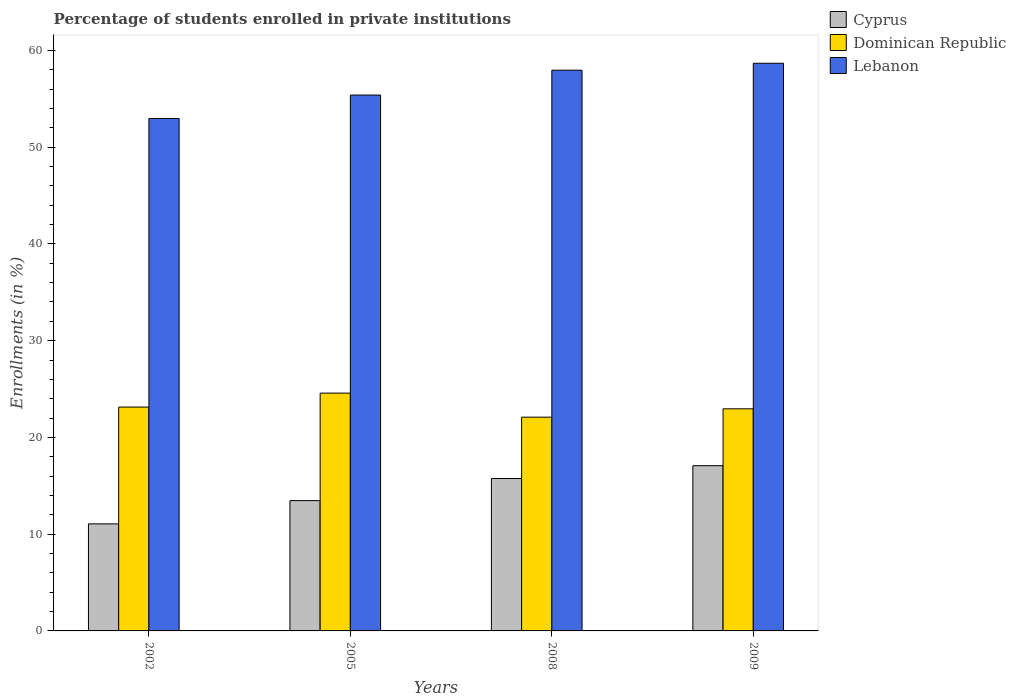In how many cases, is the number of bars for a given year not equal to the number of legend labels?
Your answer should be very brief. 0. What is the percentage of trained teachers in Lebanon in 2009?
Make the answer very short. 58.67. Across all years, what is the maximum percentage of trained teachers in Cyprus?
Give a very brief answer. 17.08. Across all years, what is the minimum percentage of trained teachers in Lebanon?
Your response must be concise. 52.96. In which year was the percentage of trained teachers in Lebanon maximum?
Ensure brevity in your answer.  2009. What is the total percentage of trained teachers in Lebanon in the graph?
Provide a succinct answer. 224.97. What is the difference between the percentage of trained teachers in Cyprus in 2008 and that in 2009?
Your answer should be very brief. -1.33. What is the difference between the percentage of trained teachers in Cyprus in 2008 and the percentage of trained teachers in Dominican Republic in 2002?
Keep it short and to the point. -7.38. What is the average percentage of trained teachers in Dominican Republic per year?
Your answer should be compact. 23.19. In the year 2002, what is the difference between the percentage of trained teachers in Cyprus and percentage of trained teachers in Lebanon?
Give a very brief answer. -41.9. What is the ratio of the percentage of trained teachers in Lebanon in 2008 to that in 2009?
Ensure brevity in your answer.  0.99. Is the percentage of trained teachers in Cyprus in 2008 less than that in 2009?
Give a very brief answer. Yes. Is the difference between the percentage of trained teachers in Cyprus in 2002 and 2008 greater than the difference between the percentage of trained teachers in Lebanon in 2002 and 2008?
Offer a very short reply. Yes. What is the difference between the highest and the second highest percentage of trained teachers in Lebanon?
Offer a terse response. 0.72. What is the difference between the highest and the lowest percentage of trained teachers in Cyprus?
Your response must be concise. 6.01. In how many years, is the percentage of trained teachers in Cyprus greater than the average percentage of trained teachers in Cyprus taken over all years?
Make the answer very short. 2. What does the 3rd bar from the left in 2008 represents?
Give a very brief answer. Lebanon. What does the 2nd bar from the right in 2009 represents?
Your answer should be very brief. Dominican Republic. Is it the case that in every year, the sum of the percentage of trained teachers in Lebanon and percentage of trained teachers in Dominican Republic is greater than the percentage of trained teachers in Cyprus?
Provide a short and direct response. Yes. How many bars are there?
Offer a terse response. 12. Are all the bars in the graph horizontal?
Make the answer very short. No. Are the values on the major ticks of Y-axis written in scientific E-notation?
Give a very brief answer. No. Does the graph contain any zero values?
Keep it short and to the point. No. Does the graph contain grids?
Your answer should be very brief. No. How many legend labels are there?
Keep it short and to the point. 3. How are the legend labels stacked?
Provide a short and direct response. Vertical. What is the title of the graph?
Make the answer very short. Percentage of students enrolled in private institutions. What is the label or title of the X-axis?
Provide a succinct answer. Years. What is the label or title of the Y-axis?
Your answer should be compact. Enrollments (in %). What is the Enrollments (in %) of Cyprus in 2002?
Your answer should be very brief. 11.06. What is the Enrollments (in %) in Dominican Republic in 2002?
Your answer should be very brief. 23.14. What is the Enrollments (in %) in Lebanon in 2002?
Your response must be concise. 52.96. What is the Enrollments (in %) in Cyprus in 2005?
Make the answer very short. 13.47. What is the Enrollments (in %) of Dominican Republic in 2005?
Provide a short and direct response. 24.58. What is the Enrollments (in %) in Lebanon in 2005?
Your answer should be very brief. 55.38. What is the Enrollments (in %) of Cyprus in 2008?
Make the answer very short. 15.75. What is the Enrollments (in %) of Dominican Republic in 2008?
Give a very brief answer. 22.09. What is the Enrollments (in %) of Lebanon in 2008?
Keep it short and to the point. 57.95. What is the Enrollments (in %) in Cyprus in 2009?
Keep it short and to the point. 17.08. What is the Enrollments (in %) of Dominican Republic in 2009?
Keep it short and to the point. 22.95. What is the Enrollments (in %) of Lebanon in 2009?
Your response must be concise. 58.67. Across all years, what is the maximum Enrollments (in %) of Cyprus?
Offer a terse response. 17.08. Across all years, what is the maximum Enrollments (in %) in Dominican Republic?
Your response must be concise. 24.58. Across all years, what is the maximum Enrollments (in %) of Lebanon?
Your answer should be very brief. 58.67. Across all years, what is the minimum Enrollments (in %) in Cyprus?
Offer a very short reply. 11.06. Across all years, what is the minimum Enrollments (in %) of Dominican Republic?
Offer a terse response. 22.09. Across all years, what is the minimum Enrollments (in %) in Lebanon?
Make the answer very short. 52.96. What is the total Enrollments (in %) in Cyprus in the graph?
Your response must be concise. 57.36. What is the total Enrollments (in %) of Dominican Republic in the graph?
Provide a short and direct response. 92.76. What is the total Enrollments (in %) in Lebanon in the graph?
Provide a short and direct response. 224.97. What is the difference between the Enrollments (in %) in Cyprus in 2002 and that in 2005?
Provide a short and direct response. -2.4. What is the difference between the Enrollments (in %) in Dominican Republic in 2002 and that in 2005?
Your response must be concise. -1.44. What is the difference between the Enrollments (in %) of Lebanon in 2002 and that in 2005?
Give a very brief answer. -2.42. What is the difference between the Enrollments (in %) in Cyprus in 2002 and that in 2008?
Your answer should be compact. -4.69. What is the difference between the Enrollments (in %) in Dominican Republic in 2002 and that in 2008?
Keep it short and to the point. 1.04. What is the difference between the Enrollments (in %) in Lebanon in 2002 and that in 2008?
Offer a terse response. -4.99. What is the difference between the Enrollments (in %) of Cyprus in 2002 and that in 2009?
Provide a short and direct response. -6.01. What is the difference between the Enrollments (in %) of Dominican Republic in 2002 and that in 2009?
Provide a succinct answer. 0.18. What is the difference between the Enrollments (in %) of Lebanon in 2002 and that in 2009?
Make the answer very short. -5.71. What is the difference between the Enrollments (in %) in Cyprus in 2005 and that in 2008?
Provide a short and direct response. -2.28. What is the difference between the Enrollments (in %) in Dominican Republic in 2005 and that in 2008?
Ensure brevity in your answer.  2.48. What is the difference between the Enrollments (in %) of Lebanon in 2005 and that in 2008?
Make the answer very short. -2.57. What is the difference between the Enrollments (in %) of Cyprus in 2005 and that in 2009?
Offer a terse response. -3.61. What is the difference between the Enrollments (in %) in Dominican Republic in 2005 and that in 2009?
Your answer should be very brief. 1.62. What is the difference between the Enrollments (in %) of Lebanon in 2005 and that in 2009?
Ensure brevity in your answer.  -3.29. What is the difference between the Enrollments (in %) in Cyprus in 2008 and that in 2009?
Your answer should be very brief. -1.33. What is the difference between the Enrollments (in %) of Dominican Republic in 2008 and that in 2009?
Give a very brief answer. -0.86. What is the difference between the Enrollments (in %) of Lebanon in 2008 and that in 2009?
Offer a terse response. -0.72. What is the difference between the Enrollments (in %) in Cyprus in 2002 and the Enrollments (in %) in Dominican Republic in 2005?
Provide a succinct answer. -13.51. What is the difference between the Enrollments (in %) in Cyprus in 2002 and the Enrollments (in %) in Lebanon in 2005?
Offer a very short reply. -44.32. What is the difference between the Enrollments (in %) of Dominican Republic in 2002 and the Enrollments (in %) of Lebanon in 2005?
Provide a succinct answer. -32.25. What is the difference between the Enrollments (in %) in Cyprus in 2002 and the Enrollments (in %) in Dominican Republic in 2008?
Provide a short and direct response. -11.03. What is the difference between the Enrollments (in %) of Cyprus in 2002 and the Enrollments (in %) of Lebanon in 2008?
Keep it short and to the point. -46.89. What is the difference between the Enrollments (in %) in Dominican Republic in 2002 and the Enrollments (in %) in Lebanon in 2008?
Offer a very short reply. -34.82. What is the difference between the Enrollments (in %) in Cyprus in 2002 and the Enrollments (in %) in Dominican Republic in 2009?
Your answer should be very brief. -11.89. What is the difference between the Enrollments (in %) in Cyprus in 2002 and the Enrollments (in %) in Lebanon in 2009?
Ensure brevity in your answer.  -47.6. What is the difference between the Enrollments (in %) in Dominican Republic in 2002 and the Enrollments (in %) in Lebanon in 2009?
Keep it short and to the point. -35.53. What is the difference between the Enrollments (in %) of Cyprus in 2005 and the Enrollments (in %) of Dominican Republic in 2008?
Provide a short and direct response. -8.63. What is the difference between the Enrollments (in %) in Cyprus in 2005 and the Enrollments (in %) in Lebanon in 2008?
Your answer should be very brief. -44.49. What is the difference between the Enrollments (in %) of Dominican Republic in 2005 and the Enrollments (in %) of Lebanon in 2008?
Provide a succinct answer. -33.38. What is the difference between the Enrollments (in %) in Cyprus in 2005 and the Enrollments (in %) in Dominican Republic in 2009?
Your answer should be compact. -9.49. What is the difference between the Enrollments (in %) in Cyprus in 2005 and the Enrollments (in %) in Lebanon in 2009?
Offer a very short reply. -45.2. What is the difference between the Enrollments (in %) of Dominican Republic in 2005 and the Enrollments (in %) of Lebanon in 2009?
Offer a terse response. -34.09. What is the difference between the Enrollments (in %) of Cyprus in 2008 and the Enrollments (in %) of Dominican Republic in 2009?
Give a very brief answer. -7.2. What is the difference between the Enrollments (in %) in Cyprus in 2008 and the Enrollments (in %) in Lebanon in 2009?
Your answer should be compact. -42.92. What is the difference between the Enrollments (in %) in Dominican Republic in 2008 and the Enrollments (in %) in Lebanon in 2009?
Provide a short and direct response. -36.58. What is the average Enrollments (in %) of Cyprus per year?
Offer a very short reply. 14.34. What is the average Enrollments (in %) in Dominican Republic per year?
Provide a succinct answer. 23.19. What is the average Enrollments (in %) in Lebanon per year?
Your answer should be compact. 56.24. In the year 2002, what is the difference between the Enrollments (in %) in Cyprus and Enrollments (in %) in Dominican Republic?
Your response must be concise. -12.07. In the year 2002, what is the difference between the Enrollments (in %) of Cyprus and Enrollments (in %) of Lebanon?
Keep it short and to the point. -41.9. In the year 2002, what is the difference between the Enrollments (in %) in Dominican Republic and Enrollments (in %) in Lebanon?
Offer a terse response. -29.83. In the year 2005, what is the difference between the Enrollments (in %) of Cyprus and Enrollments (in %) of Dominican Republic?
Provide a short and direct response. -11.11. In the year 2005, what is the difference between the Enrollments (in %) of Cyprus and Enrollments (in %) of Lebanon?
Offer a very short reply. -41.92. In the year 2005, what is the difference between the Enrollments (in %) of Dominican Republic and Enrollments (in %) of Lebanon?
Ensure brevity in your answer.  -30.81. In the year 2008, what is the difference between the Enrollments (in %) of Cyprus and Enrollments (in %) of Dominican Republic?
Your response must be concise. -6.34. In the year 2008, what is the difference between the Enrollments (in %) of Cyprus and Enrollments (in %) of Lebanon?
Offer a terse response. -42.2. In the year 2008, what is the difference between the Enrollments (in %) in Dominican Republic and Enrollments (in %) in Lebanon?
Make the answer very short. -35.86. In the year 2009, what is the difference between the Enrollments (in %) in Cyprus and Enrollments (in %) in Dominican Republic?
Your response must be concise. -5.88. In the year 2009, what is the difference between the Enrollments (in %) of Cyprus and Enrollments (in %) of Lebanon?
Your response must be concise. -41.59. In the year 2009, what is the difference between the Enrollments (in %) of Dominican Republic and Enrollments (in %) of Lebanon?
Provide a succinct answer. -35.71. What is the ratio of the Enrollments (in %) in Cyprus in 2002 to that in 2005?
Ensure brevity in your answer.  0.82. What is the ratio of the Enrollments (in %) of Dominican Republic in 2002 to that in 2005?
Keep it short and to the point. 0.94. What is the ratio of the Enrollments (in %) of Lebanon in 2002 to that in 2005?
Offer a terse response. 0.96. What is the ratio of the Enrollments (in %) of Cyprus in 2002 to that in 2008?
Give a very brief answer. 0.7. What is the ratio of the Enrollments (in %) in Dominican Republic in 2002 to that in 2008?
Offer a terse response. 1.05. What is the ratio of the Enrollments (in %) in Lebanon in 2002 to that in 2008?
Provide a succinct answer. 0.91. What is the ratio of the Enrollments (in %) in Cyprus in 2002 to that in 2009?
Offer a very short reply. 0.65. What is the ratio of the Enrollments (in %) of Dominican Republic in 2002 to that in 2009?
Offer a terse response. 1.01. What is the ratio of the Enrollments (in %) in Lebanon in 2002 to that in 2009?
Offer a very short reply. 0.9. What is the ratio of the Enrollments (in %) in Cyprus in 2005 to that in 2008?
Offer a very short reply. 0.85. What is the ratio of the Enrollments (in %) in Dominican Republic in 2005 to that in 2008?
Provide a succinct answer. 1.11. What is the ratio of the Enrollments (in %) of Lebanon in 2005 to that in 2008?
Offer a terse response. 0.96. What is the ratio of the Enrollments (in %) of Cyprus in 2005 to that in 2009?
Offer a terse response. 0.79. What is the ratio of the Enrollments (in %) of Dominican Republic in 2005 to that in 2009?
Offer a terse response. 1.07. What is the ratio of the Enrollments (in %) in Lebanon in 2005 to that in 2009?
Make the answer very short. 0.94. What is the ratio of the Enrollments (in %) of Cyprus in 2008 to that in 2009?
Ensure brevity in your answer.  0.92. What is the ratio of the Enrollments (in %) of Dominican Republic in 2008 to that in 2009?
Keep it short and to the point. 0.96. What is the difference between the highest and the second highest Enrollments (in %) in Cyprus?
Your answer should be very brief. 1.33. What is the difference between the highest and the second highest Enrollments (in %) in Dominican Republic?
Ensure brevity in your answer.  1.44. What is the difference between the highest and the second highest Enrollments (in %) in Lebanon?
Give a very brief answer. 0.72. What is the difference between the highest and the lowest Enrollments (in %) of Cyprus?
Give a very brief answer. 6.01. What is the difference between the highest and the lowest Enrollments (in %) in Dominican Republic?
Make the answer very short. 2.48. What is the difference between the highest and the lowest Enrollments (in %) of Lebanon?
Ensure brevity in your answer.  5.71. 